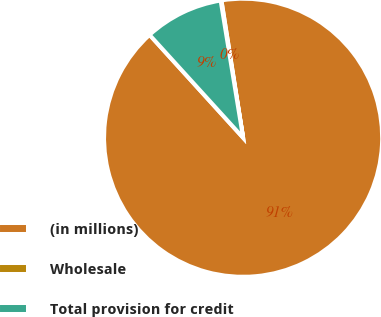Convert chart to OTSL. <chart><loc_0><loc_0><loc_500><loc_500><pie_chart><fcel>(in millions)<fcel>Wholesale<fcel>Total provision for credit<nl><fcel>90.75%<fcel>0.09%<fcel>9.16%<nl></chart> 